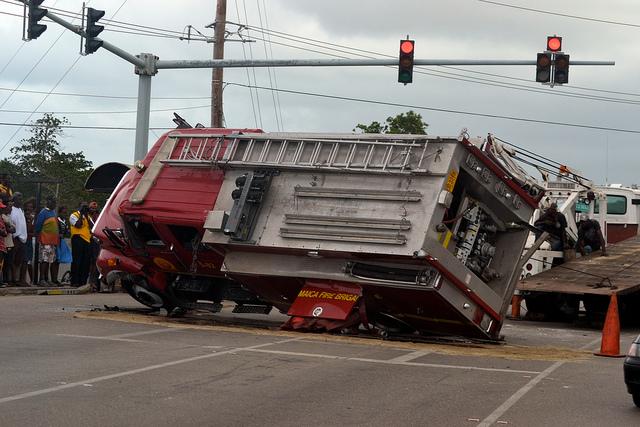Is there a ladder on the truck?
Keep it brief. Yes. What kind of truck tipped over?
Be succinct. Fire truck. How many traffic lights do you see?
Concise answer only. 4. 